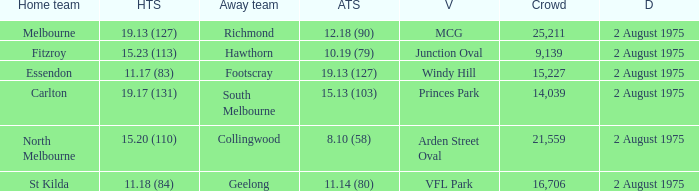When was a game played where the away team scored 10.19 (79)? 2 August 1975. 